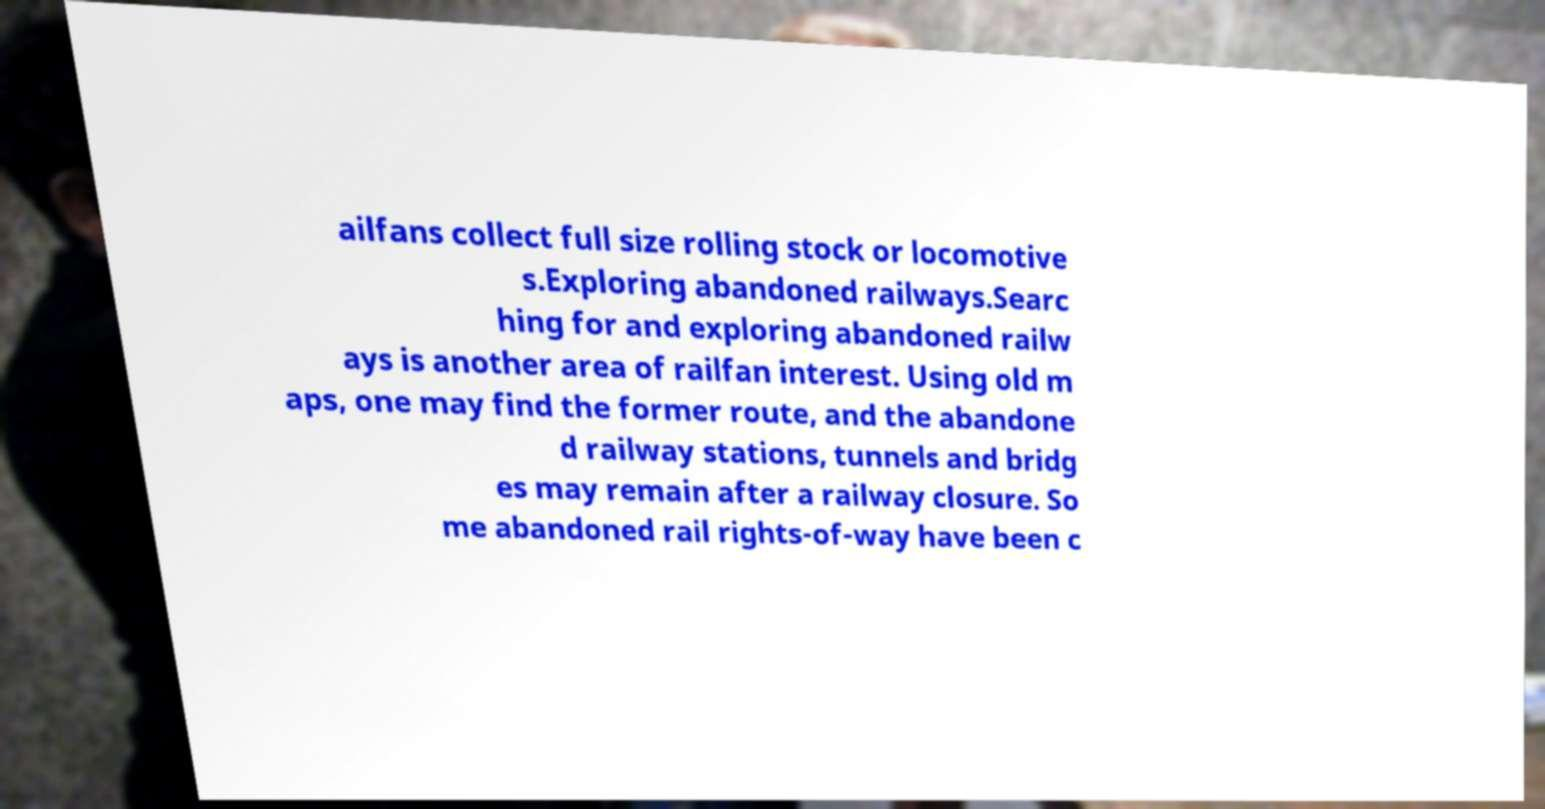Could you extract and type out the text from this image? ailfans collect full size rolling stock or locomotive s.Exploring abandoned railways.Searc hing for and exploring abandoned railw ays is another area of railfan interest. Using old m aps, one may find the former route, and the abandone d railway stations, tunnels and bridg es may remain after a railway closure. So me abandoned rail rights-of-way have been c 